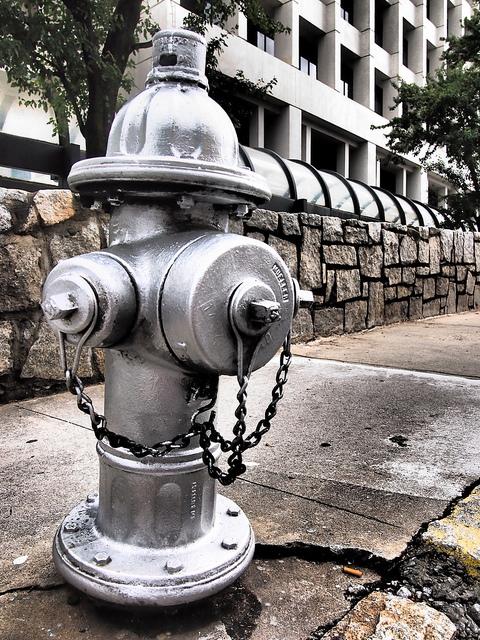What is the sidewalk lined with in the background?
Concise answer only. Brick wall. Does the ground appear wet?
Concise answer only. No. What color is the fire hydrant?
Short answer required. Silver. 